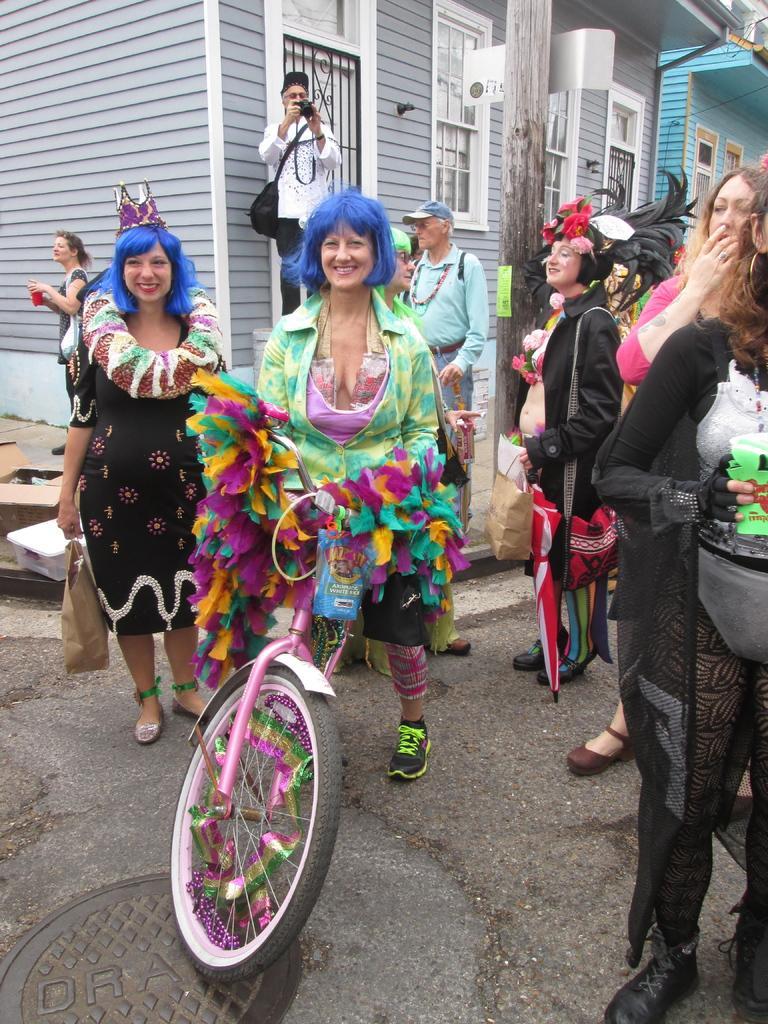How would you summarize this image in a sentence or two? Group of people standing and these three persons are wear decorative items,this person holding camera and wear bag and this person sitting and holding bicycle.. On the background we can see houses,window,wall,wooden pole. 